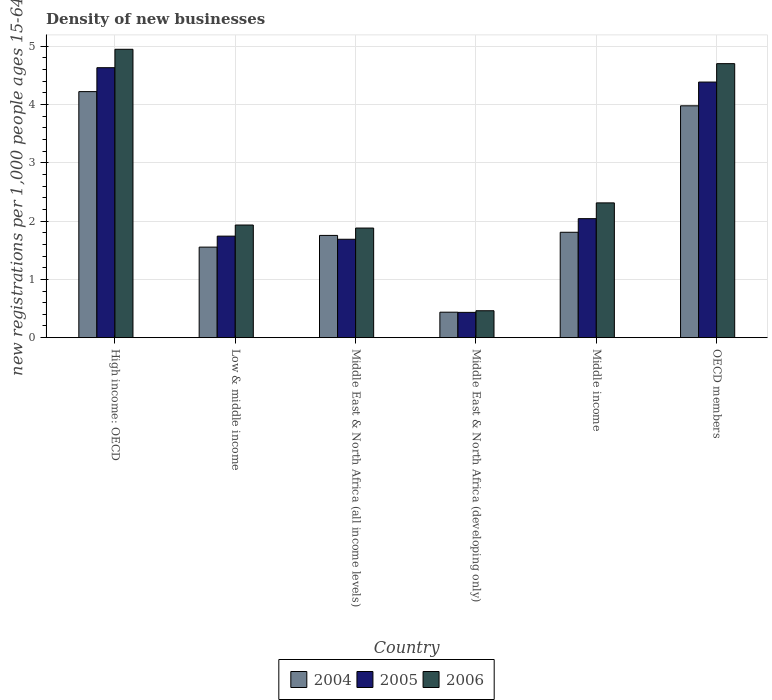How many different coloured bars are there?
Give a very brief answer. 3. Are the number of bars per tick equal to the number of legend labels?
Your answer should be very brief. Yes. Are the number of bars on each tick of the X-axis equal?
Keep it short and to the point. Yes. How many bars are there on the 3rd tick from the right?
Make the answer very short. 3. What is the label of the 5th group of bars from the left?
Make the answer very short. Middle income. In how many cases, is the number of bars for a given country not equal to the number of legend labels?
Your answer should be compact. 0. What is the number of new registrations in 2004 in OECD members?
Ensure brevity in your answer.  3.98. Across all countries, what is the maximum number of new registrations in 2004?
Your answer should be very brief. 4.22. Across all countries, what is the minimum number of new registrations in 2004?
Your answer should be compact. 0.44. In which country was the number of new registrations in 2006 maximum?
Your response must be concise. High income: OECD. In which country was the number of new registrations in 2005 minimum?
Provide a succinct answer. Middle East & North Africa (developing only). What is the total number of new registrations in 2006 in the graph?
Provide a short and direct response. 16.23. What is the difference between the number of new registrations in 2006 in Middle income and that in OECD members?
Provide a succinct answer. -2.39. What is the difference between the number of new registrations in 2004 in Low & middle income and the number of new registrations in 2005 in Middle income?
Your response must be concise. -0.49. What is the average number of new registrations in 2004 per country?
Give a very brief answer. 2.29. What is the difference between the number of new registrations of/in 2005 and number of new registrations of/in 2006 in Middle East & North Africa (all income levels)?
Give a very brief answer. -0.19. In how many countries, is the number of new registrations in 2004 greater than 0.4?
Ensure brevity in your answer.  6. What is the ratio of the number of new registrations in 2005 in Middle East & North Africa (developing only) to that in Middle income?
Make the answer very short. 0.21. Is the number of new registrations in 2004 in High income: OECD less than that in Middle East & North Africa (developing only)?
Offer a terse response. No. Is the difference between the number of new registrations in 2005 in Middle income and OECD members greater than the difference between the number of new registrations in 2006 in Middle income and OECD members?
Your response must be concise. Yes. What is the difference between the highest and the second highest number of new registrations in 2005?
Ensure brevity in your answer.  -2.59. What is the difference between the highest and the lowest number of new registrations in 2005?
Provide a succinct answer. 4.2. What does the 1st bar from the left in Middle East & North Africa (all income levels) represents?
Ensure brevity in your answer.  2004. Is it the case that in every country, the sum of the number of new registrations in 2005 and number of new registrations in 2006 is greater than the number of new registrations in 2004?
Your response must be concise. Yes. How many bars are there?
Provide a short and direct response. 18. How many countries are there in the graph?
Offer a very short reply. 6. Does the graph contain any zero values?
Your answer should be compact. No. Does the graph contain grids?
Provide a short and direct response. Yes. How are the legend labels stacked?
Your answer should be compact. Horizontal. What is the title of the graph?
Your answer should be compact. Density of new businesses. What is the label or title of the Y-axis?
Give a very brief answer. New registrations per 1,0 people ages 15-64. What is the new registrations per 1,000 people ages 15-64 of 2004 in High income: OECD?
Your answer should be very brief. 4.22. What is the new registrations per 1,000 people ages 15-64 in 2005 in High income: OECD?
Provide a short and direct response. 4.63. What is the new registrations per 1,000 people ages 15-64 of 2006 in High income: OECD?
Provide a short and direct response. 4.94. What is the new registrations per 1,000 people ages 15-64 of 2004 in Low & middle income?
Your response must be concise. 1.55. What is the new registrations per 1,000 people ages 15-64 in 2005 in Low & middle income?
Make the answer very short. 1.74. What is the new registrations per 1,000 people ages 15-64 in 2006 in Low & middle income?
Offer a terse response. 1.93. What is the new registrations per 1,000 people ages 15-64 in 2004 in Middle East & North Africa (all income levels)?
Provide a succinct answer. 1.75. What is the new registrations per 1,000 people ages 15-64 in 2005 in Middle East & North Africa (all income levels)?
Keep it short and to the point. 1.69. What is the new registrations per 1,000 people ages 15-64 in 2006 in Middle East & North Africa (all income levels)?
Provide a succinct answer. 1.88. What is the new registrations per 1,000 people ages 15-64 of 2004 in Middle East & North Africa (developing only)?
Keep it short and to the point. 0.44. What is the new registrations per 1,000 people ages 15-64 of 2005 in Middle East & North Africa (developing only)?
Give a very brief answer. 0.43. What is the new registrations per 1,000 people ages 15-64 of 2006 in Middle East & North Africa (developing only)?
Give a very brief answer. 0.46. What is the new registrations per 1,000 people ages 15-64 of 2004 in Middle income?
Make the answer very short. 1.81. What is the new registrations per 1,000 people ages 15-64 of 2005 in Middle income?
Provide a short and direct response. 2.04. What is the new registrations per 1,000 people ages 15-64 in 2006 in Middle income?
Your answer should be very brief. 2.31. What is the new registrations per 1,000 people ages 15-64 in 2004 in OECD members?
Keep it short and to the point. 3.98. What is the new registrations per 1,000 people ages 15-64 of 2005 in OECD members?
Your response must be concise. 4.38. What is the new registrations per 1,000 people ages 15-64 in 2006 in OECD members?
Offer a terse response. 4.7. Across all countries, what is the maximum new registrations per 1,000 people ages 15-64 in 2004?
Your response must be concise. 4.22. Across all countries, what is the maximum new registrations per 1,000 people ages 15-64 in 2005?
Your answer should be compact. 4.63. Across all countries, what is the maximum new registrations per 1,000 people ages 15-64 of 2006?
Provide a short and direct response. 4.94. Across all countries, what is the minimum new registrations per 1,000 people ages 15-64 in 2004?
Your answer should be very brief. 0.44. Across all countries, what is the minimum new registrations per 1,000 people ages 15-64 of 2005?
Provide a succinct answer. 0.43. Across all countries, what is the minimum new registrations per 1,000 people ages 15-64 in 2006?
Offer a terse response. 0.46. What is the total new registrations per 1,000 people ages 15-64 in 2004 in the graph?
Offer a terse response. 13.74. What is the total new registrations per 1,000 people ages 15-64 of 2005 in the graph?
Offer a very short reply. 14.92. What is the total new registrations per 1,000 people ages 15-64 of 2006 in the graph?
Offer a terse response. 16.23. What is the difference between the new registrations per 1,000 people ages 15-64 in 2004 in High income: OECD and that in Low & middle income?
Your answer should be very brief. 2.67. What is the difference between the new registrations per 1,000 people ages 15-64 in 2005 in High income: OECD and that in Low & middle income?
Your answer should be compact. 2.89. What is the difference between the new registrations per 1,000 people ages 15-64 of 2006 in High income: OECD and that in Low & middle income?
Make the answer very short. 3.01. What is the difference between the new registrations per 1,000 people ages 15-64 of 2004 in High income: OECD and that in Middle East & North Africa (all income levels)?
Offer a very short reply. 2.47. What is the difference between the new registrations per 1,000 people ages 15-64 of 2005 in High income: OECD and that in Middle East & North Africa (all income levels)?
Offer a very short reply. 2.94. What is the difference between the new registrations per 1,000 people ages 15-64 of 2006 in High income: OECD and that in Middle East & North Africa (all income levels)?
Provide a succinct answer. 3.07. What is the difference between the new registrations per 1,000 people ages 15-64 of 2004 in High income: OECD and that in Middle East & North Africa (developing only)?
Your answer should be very brief. 3.78. What is the difference between the new registrations per 1,000 people ages 15-64 in 2005 in High income: OECD and that in Middle East & North Africa (developing only)?
Offer a very short reply. 4.2. What is the difference between the new registrations per 1,000 people ages 15-64 of 2006 in High income: OECD and that in Middle East & North Africa (developing only)?
Ensure brevity in your answer.  4.48. What is the difference between the new registrations per 1,000 people ages 15-64 in 2004 in High income: OECD and that in Middle income?
Your answer should be compact. 2.41. What is the difference between the new registrations per 1,000 people ages 15-64 of 2005 in High income: OECD and that in Middle income?
Keep it short and to the point. 2.59. What is the difference between the new registrations per 1,000 people ages 15-64 of 2006 in High income: OECD and that in Middle income?
Provide a succinct answer. 2.63. What is the difference between the new registrations per 1,000 people ages 15-64 in 2004 in High income: OECD and that in OECD members?
Offer a terse response. 0.24. What is the difference between the new registrations per 1,000 people ages 15-64 in 2005 in High income: OECD and that in OECD members?
Offer a very short reply. 0.25. What is the difference between the new registrations per 1,000 people ages 15-64 of 2006 in High income: OECD and that in OECD members?
Offer a terse response. 0.25. What is the difference between the new registrations per 1,000 people ages 15-64 of 2004 in Low & middle income and that in Middle East & North Africa (all income levels)?
Provide a succinct answer. -0.2. What is the difference between the new registrations per 1,000 people ages 15-64 of 2005 in Low & middle income and that in Middle East & North Africa (all income levels)?
Your answer should be very brief. 0.05. What is the difference between the new registrations per 1,000 people ages 15-64 of 2006 in Low & middle income and that in Middle East & North Africa (all income levels)?
Your answer should be very brief. 0.05. What is the difference between the new registrations per 1,000 people ages 15-64 of 2004 in Low & middle income and that in Middle East & North Africa (developing only)?
Offer a very short reply. 1.12. What is the difference between the new registrations per 1,000 people ages 15-64 of 2005 in Low & middle income and that in Middle East & North Africa (developing only)?
Ensure brevity in your answer.  1.31. What is the difference between the new registrations per 1,000 people ages 15-64 of 2006 in Low & middle income and that in Middle East & North Africa (developing only)?
Give a very brief answer. 1.47. What is the difference between the new registrations per 1,000 people ages 15-64 of 2004 in Low & middle income and that in Middle income?
Give a very brief answer. -0.25. What is the difference between the new registrations per 1,000 people ages 15-64 in 2005 in Low & middle income and that in Middle income?
Make the answer very short. -0.3. What is the difference between the new registrations per 1,000 people ages 15-64 of 2006 in Low & middle income and that in Middle income?
Your response must be concise. -0.38. What is the difference between the new registrations per 1,000 people ages 15-64 in 2004 in Low & middle income and that in OECD members?
Your answer should be compact. -2.42. What is the difference between the new registrations per 1,000 people ages 15-64 of 2005 in Low & middle income and that in OECD members?
Provide a succinct answer. -2.64. What is the difference between the new registrations per 1,000 people ages 15-64 of 2006 in Low & middle income and that in OECD members?
Keep it short and to the point. -2.77. What is the difference between the new registrations per 1,000 people ages 15-64 of 2004 in Middle East & North Africa (all income levels) and that in Middle East & North Africa (developing only)?
Provide a short and direct response. 1.32. What is the difference between the new registrations per 1,000 people ages 15-64 in 2005 in Middle East & North Africa (all income levels) and that in Middle East & North Africa (developing only)?
Provide a short and direct response. 1.25. What is the difference between the new registrations per 1,000 people ages 15-64 of 2006 in Middle East & North Africa (all income levels) and that in Middle East & North Africa (developing only)?
Offer a very short reply. 1.42. What is the difference between the new registrations per 1,000 people ages 15-64 of 2004 in Middle East & North Africa (all income levels) and that in Middle income?
Offer a terse response. -0.05. What is the difference between the new registrations per 1,000 people ages 15-64 in 2005 in Middle East & North Africa (all income levels) and that in Middle income?
Your answer should be compact. -0.35. What is the difference between the new registrations per 1,000 people ages 15-64 in 2006 in Middle East & North Africa (all income levels) and that in Middle income?
Provide a short and direct response. -0.43. What is the difference between the new registrations per 1,000 people ages 15-64 of 2004 in Middle East & North Africa (all income levels) and that in OECD members?
Your answer should be very brief. -2.22. What is the difference between the new registrations per 1,000 people ages 15-64 of 2005 in Middle East & North Africa (all income levels) and that in OECD members?
Provide a short and direct response. -2.7. What is the difference between the new registrations per 1,000 people ages 15-64 of 2006 in Middle East & North Africa (all income levels) and that in OECD members?
Keep it short and to the point. -2.82. What is the difference between the new registrations per 1,000 people ages 15-64 of 2004 in Middle East & North Africa (developing only) and that in Middle income?
Keep it short and to the point. -1.37. What is the difference between the new registrations per 1,000 people ages 15-64 of 2005 in Middle East & North Africa (developing only) and that in Middle income?
Give a very brief answer. -1.61. What is the difference between the new registrations per 1,000 people ages 15-64 in 2006 in Middle East & North Africa (developing only) and that in Middle income?
Offer a very short reply. -1.85. What is the difference between the new registrations per 1,000 people ages 15-64 in 2004 in Middle East & North Africa (developing only) and that in OECD members?
Keep it short and to the point. -3.54. What is the difference between the new registrations per 1,000 people ages 15-64 in 2005 in Middle East & North Africa (developing only) and that in OECD members?
Your response must be concise. -3.95. What is the difference between the new registrations per 1,000 people ages 15-64 in 2006 in Middle East & North Africa (developing only) and that in OECD members?
Ensure brevity in your answer.  -4.24. What is the difference between the new registrations per 1,000 people ages 15-64 of 2004 in Middle income and that in OECD members?
Your response must be concise. -2.17. What is the difference between the new registrations per 1,000 people ages 15-64 in 2005 in Middle income and that in OECD members?
Your answer should be compact. -2.34. What is the difference between the new registrations per 1,000 people ages 15-64 of 2006 in Middle income and that in OECD members?
Your response must be concise. -2.39. What is the difference between the new registrations per 1,000 people ages 15-64 in 2004 in High income: OECD and the new registrations per 1,000 people ages 15-64 in 2005 in Low & middle income?
Your answer should be compact. 2.48. What is the difference between the new registrations per 1,000 people ages 15-64 of 2004 in High income: OECD and the new registrations per 1,000 people ages 15-64 of 2006 in Low & middle income?
Offer a very short reply. 2.29. What is the difference between the new registrations per 1,000 people ages 15-64 in 2005 in High income: OECD and the new registrations per 1,000 people ages 15-64 in 2006 in Low & middle income?
Ensure brevity in your answer.  2.7. What is the difference between the new registrations per 1,000 people ages 15-64 in 2004 in High income: OECD and the new registrations per 1,000 people ages 15-64 in 2005 in Middle East & North Africa (all income levels)?
Ensure brevity in your answer.  2.53. What is the difference between the new registrations per 1,000 people ages 15-64 in 2004 in High income: OECD and the new registrations per 1,000 people ages 15-64 in 2006 in Middle East & North Africa (all income levels)?
Make the answer very short. 2.34. What is the difference between the new registrations per 1,000 people ages 15-64 of 2005 in High income: OECD and the new registrations per 1,000 people ages 15-64 of 2006 in Middle East & North Africa (all income levels)?
Keep it short and to the point. 2.75. What is the difference between the new registrations per 1,000 people ages 15-64 of 2004 in High income: OECD and the new registrations per 1,000 people ages 15-64 of 2005 in Middle East & North Africa (developing only)?
Make the answer very short. 3.79. What is the difference between the new registrations per 1,000 people ages 15-64 of 2004 in High income: OECD and the new registrations per 1,000 people ages 15-64 of 2006 in Middle East & North Africa (developing only)?
Give a very brief answer. 3.76. What is the difference between the new registrations per 1,000 people ages 15-64 of 2005 in High income: OECD and the new registrations per 1,000 people ages 15-64 of 2006 in Middle East & North Africa (developing only)?
Your answer should be very brief. 4.17. What is the difference between the new registrations per 1,000 people ages 15-64 of 2004 in High income: OECD and the new registrations per 1,000 people ages 15-64 of 2005 in Middle income?
Ensure brevity in your answer.  2.18. What is the difference between the new registrations per 1,000 people ages 15-64 in 2004 in High income: OECD and the new registrations per 1,000 people ages 15-64 in 2006 in Middle income?
Your answer should be very brief. 1.91. What is the difference between the new registrations per 1,000 people ages 15-64 in 2005 in High income: OECD and the new registrations per 1,000 people ages 15-64 in 2006 in Middle income?
Offer a terse response. 2.32. What is the difference between the new registrations per 1,000 people ages 15-64 of 2004 in High income: OECD and the new registrations per 1,000 people ages 15-64 of 2005 in OECD members?
Provide a short and direct response. -0.16. What is the difference between the new registrations per 1,000 people ages 15-64 in 2004 in High income: OECD and the new registrations per 1,000 people ages 15-64 in 2006 in OECD members?
Your answer should be compact. -0.48. What is the difference between the new registrations per 1,000 people ages 15-64 of 2005 in High income: OECD and the new registrations per 1,000 people ages 15-64 of 2006 in OECD members?
Your answer should be very brief. -0.07. What is the difference between the new registrations per 1,000 people ages 15-64 of 2004 in Low & middle income and the new registrations per 1,000 people ages 15-64 of 2005 in Middle East & North Africa (all income levels)?
Your answer should be very brief. -0.13. What is the difference between the new registrations per 1,000 people ages 15-64 in 2004 in Low & middle income and the new registrations per 1,000 people ages 15-64 in 2006 in Middle East & North Africa (all income levels)?
Your answer should be very brief. -0.33. What is the difference between the new registrations per 1,000 people ages 15-64 in 2005 in Low & middle income and the new registrations per 1,000 people ages 15-64 in 2006 in Middle East & North Africa (all income levels)?
Your answer should be very brief. -0.14. What is the difference between the new registrations per 1,000 people ages 15-64 of 2004 in Low & middle income and the new registrations per 1,000 people ages 15-64 of 2005 in Middle East & North Africa (developing only)?
Offer a very short reply. 1.12. What is the difference between the new registrations per 1,000 people ages 15-64 of 2005 in Low & middle income and the new registrations per 1,000 people ages 15-64 of 2006 in Middle East & North Africa (developing only)?
Offer a very short reply. 1.28. What is the difference between the new registrations per 1,000 people ages 15-64 in 2004 in Low & middle income and the new registrations per 1,000 people ages 15-64 in 2005 in Middle income?
Offer a terse response. -0.49. What is the difference between the new registrations per 1,000 people ages 15-64 of 2004 in Low & middle income and the new registrations per 1,000 people ages 15-64 of 2006 in Middle income?
Your response must be concise. -0.76. What is the difference between the new registrations per 1,000 people ages 15-64 in 2005 in Low & middle income and the new registrations per 1,000 people ages 15-64 in 2006 in Middle income?
Your answer should be compact. -0.57. What is the difference between the new registrations per 1,000 people ages 15-64 in 2004 in Low & middle income and the new registrations per 1,000 people ages 15-64 in 2005 in OECD members?
Your answer should be compact. -2.83. What is the difference between the new registrations per 1,000 people ages 15-64 in 2004 in Low & middle income and the new registrations per 1,000 people ages 15-64 in 2006 in OECD members?
Provide a short and direct response. -3.15. What is the difference between the new registrations per 1,000 people ages 15-64 in 2005 in Low & middle income and the new registrations per 1,000 people ages 15-64 in 2006 in OECD members?
Your answer should be compact. -2.96. What is the difference between the new registrations per 1,000 people ages 15-64 of 2004 in Middle East & North Africa (all income levels) and the new registrations per 1,000 people ages 15-64 of 2005 in Middle East & North Africa (developing only)?
Ensure brevity in your answer.  1.32. What is the difference between the new registrations per 1,000 people ages 15-64 in 2004 in Middle East & North Africa (all income levels) and the new registrations per 1,000 people ages 15-64 in 2006 in Middle East & North Africa (developing only)?
Make the answer very short. 1.29. What is the difference between the new registrations per 1,000 people ages 15-64 in 2005 in Middle East & North Africa (all income levels) and the new registrations per 1,000 people ages 15-64 in 2006 in Middle East & North Africa (developing only)?
Your answer should be compact. 1.23. What is the difference between the new registrations per 1,000 people ages 15-64 of 2004 in Middle East & North Africa (all income levels) and the new registrations per 1,000 people ages 15-64 of 2005 in Middle income?
Offer a terse response. -0.29. What is the difference between the new registrations per 1,000 people ages 15-64 in 2004 in Middle East & North Africa (all income levels) and the new registrations per 1,000 people ages 15-64 in 2006 in Middle income?
Give a very brief answer. -0.56. What is the difference between the new registrations per 1,000 people ages 15-64 in 2005 in Middle East & North Africa (all income levels) and the new registrations per 1,000 people ages 15-64 in 2006 in Middle income?
Offer a terse response. -0.62. What is the difference between the new registrations per 1,000 people ages 15-64 in 2004 in Middle East & North Africa (all income levels) and the new registrations per 1,000 people ages 15-64 in 2005 in OECD members?
Offer a terse response. -2.63. What is the difference between the new registrations per 1,000 people ages 15-64 in 2004 in Middle East & North Africa (all income levels) and the new registrations per 1,000 people ages 15-64 in 2006 in OECD members?
Ensure brevity in your answer.  -2.95. What is the difference between the new registrations per 1,000 people ages 15-64 of 2005 in Middle East & North Africa (all income levels) and the new registrations per 1,000 people ages 15-64 of 2006 in OECD members?
Ensure brevity in your answer.  -3.01. What is the difference between the new registrations per 1,000 people ages 15-64 of 2004 in Middle East & North Africa (developing only) and the new registrations per 1,000 people ages 15-64 of 2005 in Middle income?
Give a very brief answer. -1.6. What is the difference between the new registrations per 1,000 people ages 15-64 in 2004 in Middle East & North Africa (developing only) and the new registrations per 1,000 people ages 15-64 in 2006 in Middle income?
Offer a terse response. -1.87. What is the difference between the new registrations per 1,000 people ages 15-64 in 2005 in Middle East & North Africa (developing only) and the new registrations per 1,000 people ages 15-64 in 2006 in Middle income?
Offer a terse response. -1.88. What is the difference between the new registrations per 1,000 people ages 15-64 in 2004 in Middle East & North Africa (developing only) and the new registrations per 1,000 people ages 15-64 in 2005 in OECD members?
Make the answer very short. -3.95. What is the difference between the new registrations per 1,000 people ages 15-64 in 2004 in Middle East & North Africa (developing only) and the new registrations per 1,000 people ages 15-64 in 2006 in OECD members?
Offer a terse response. -4.26. What is the difference between the new registrations per 1,000 people ages 15-64 in 2005 in Middle East & North Africa (developing only) and the new registrations per 1,000 people ages 15-64 in 2006 in OECD members?
Provide a short and direct response. -4.26. What is the difference between the new registrations per 1,000 people ages 15-64 in 2004 in Middle income and the new registrations per 1,000 people ages 15-64 in 2005 in OECD members?
Ensure brevity in your answer.  -2.58. What is the difference between the new registrations per 1,000 people ages 15-64 in 2004 in Middle income and the new registrations per 1,000 people ages 15-64 in 2006 in OECD members?
Give a very brief answer. -2.89. What is the difference between the new registrations per 1,000 people ages 15-64 in 2005 in Middle income and the new registrations per 1,000 people ages 15-64 in 2006 in OECD members?
Offer a very short reply. -2.66. What is the average new registrations per 1,000 people ages 15-64 in 2004 per country?
Your answer should be compact. 2.29. What is the average new registrations per 1,000 people ages 15-64 in 2005 per country?
Provide a short and direct response. 2.49. What is the average new registrations per 1,000 people ages 15-64 of 2006 per country?
Your response must be concise. 2.7. What is the difference between the new registrations per 1,000 people ages 15-64 of 2004 and new registrations per 1,000 people ages 15-64 of 2005 in High income: OECD?
Give a very brief answer. -0.41. What is the difference between the new registrations per 1,000 people ages 15-64 of 2004 and new registrations per 1,000 people ages 15-64 of 2006 in High income: OECD?
Your answer should be very brief. -0.73. What is the difference between the new registrations per 1,000 people ages 15-64 of 2005 and new registrations per 1,000 people ages 15-64 of 2006 in High income: OECD?
Offer a very short reply. -0.32. What is the difference between the new registrations per 1,000 people ages 15-64 of 2004 and new registrations per 1,000 people ages 15-64 of 2005 in Low & middle income?
Your answer should be compact. -0.19. What is the difference between the new registrations per 1,000 people ages 15-64 of 2004 and new registrations per 1,000 people ages 15-64 of 2006 in Low & middle income?
Provide a succinct answer. -0.38. What is the difference between the new registrations per 1,000 people ages 15-64 of 2005 and new registrations per 1,000 people ages 15-64 of 2006 in Low & middle income?
Your response must be concise. -0.19. What is the difference between the new registrations per 1,000 people ages 15-64 in 2004 and new registrations per 1,000 people ages 15-64 in 2005 in Middle East & North Africa (all income levels)?
Ensure brevity in your answer.  0.07. What is the difference between the new registrations per 1,000 people ages 15-64 of 2004 and new registrations per 1,000 people ages 15-64 of 2006 in Middle East & North Africa (all income levels)?
Offer a terse response. -0.13. What is the difference between the new registrations per 1,000 people ages 15-64 of 2005 and new registrations per 1,000 people ages 15-64 of 2006 in Middle East & North Africa (all income levels)?
Provide a succinct answer. -0.19. What is the difference between the new registrations per 1,000 people ages 15-64 of 2004 and new registrations per 1,000 people ages 15-64 of 2005 in Middle East & North Africa (developing only)?
Make the answer very short. 0. What is the difference between the new registrations per 1,000 people ages 15-64 of 2004 and new registrations per 1,000 people ages 15-64 of 2006 in Middle East & North Africa (developing only)?
Give a very brief answer. -0.02. What is the difference between the new registrations per 1,000 people ages 15-64 in 2005 and new registrations per 1,000 people ages 15-64 in 2006 in Middle East & North Africa (developing only)?
Make the answer very short. -0.03. What is the difference between the new registrations per 1,000 people ages 15-64 in 2004 and new registrations per 1,000 people ages 15-64 in 2005 in Middle income?
Give a very brief answer. -0.23. What is the difference between the new registrations per 1,000 people ages 15-64 in 2004 and new registrations per 1,000 people ages 15-64 in 2006 in Middle income?
Offer a very short reply. -0.5. What is the difference between the new registrations per 1,000 people ages 15-64 in 2005 and new registrations per 1,000 people ages 15-64 in 2006 in Middle income?
Ensure brevity in your answer.  -0.27. What is the difference between the new registrations per 1,000 people ages 15-64 in 2004 and new registrations per 1,000 people ages 15-64 in 2005 in OECD members?
Offer a very short reply. -0.41. What is the difference between the new registrations per 1,000 people ages 15-64 of 2004 and new registrations per 1,000 people ages 15-64 of 2006 in OECD members?
Make the answer very short. -0.72. What is the difference between the new registrations per 1,000 people ages 15-64 in 2005 and new registrations per 1,000 people ages 15-64 in 2006 in OECD members?
Offer a very short reply. -0.32. What is the ratio of the new registrations per 1,000 people ages 15-64 in 2004 in High income: OECD to that in Low & middle income?
Your answer should be compact. 2.72. What is the ratio of the new registrations per 1,000 people ages 15-64 of 2005 in High income: OECD to that in Low & middle income?
Make the answer very short. 2.66. What is the ratio of the new registrations per 1,000 people ages 15-64 in 2006 in High income: OECD to that in Low & middle income?
Ensure brevity in your answer.  2.56. What is the ratio of the new registrations per 1,000 people ages 15-64 of 2004 in High income: OECD to that in Middle East & North Africa (all income levels)?
Your response must be concise. 2.41. What is the ratio of the new registrations per 1,000 people ages 15-64 in 2005 in High income: OECD to that in Middle East & North Africa (all income levels)?
Provide a succinct answer. 2.74. What is the ratio of the new registrations per 1,000 people ages 15-64 of 2006 in High income: OECD to that in Middle East & North Africa (all income levels)?
Your answer should be compact. 2.63. What is the ratio of the new registrations per 1,000 people ages 15-64 in 2004 in High income: OECD to that in Middle East & North Africa (developing only)?
Your answer should be compact. 9.66. What is the ratio of the new registrations per 1,000 people ages 15-64 in 2005 in High income: OECD to that in Middle East & North Africa (developing only)?
Ensure brevity in your answer.  10.67. What is the ratio of the new registrations per 1,000 people ages 15-64 in 2006 in High income: OECD to that in Middle East & North Africa (developing only)?
Provide a succinct answer. 10.71. What is the ratio of the new registrations per 1,000 people ages 15-64 in 2004 in High income: OECD to that in Middle income?
Give a very brief answer. 2.33. What is the ratio of the new registrations per 1,000 people ages 15-64 in 2005 in High income: OECD to that in Middle income?
Give a very brief answer. 2.27. What is the ratio of the new registrations per 1,000 people ages 15-64 of 2006 in High income: OECD to that in Middle income?
Your response must be concise. 2.14. What is the ratio of the new registrations per 1,000 people ages 15-64 of 2004 in High income: OECD to that in OECD members?
Keep it short and to the point. 1.06. What is the ratio of the new registrations per 1,000 people ages 15-64 of 2005 in High income: OECD to that in OECD members?
Your response must be concise. 1.06. What is the ratio of the new registrations per 1,000 people ages 15-64 in 2006 in High income: OECD to that in OECD members?
Ensure brevity in your answer.  1.05. What is the ratio of the new registrations per 1,000 people ages 15-64 in 2004 in Low & middle income to that in Middle East & North Africa (all income levels)?
Provide a succinct answer. 0.89. What is the ratio of the new registrations per 1,000 people ages 15-64 in 2005 in Low & middle income to that in Middle East & North Africa (all income levels)?
Make the answer very short. 1.03. What is the ratio of the new registrations per 1,000 people ages 15-64 of 2006 in Low & middle income to that in Middle East & North Africa (all income levels)?
Provide a succinct answer. 1.03. What is the ratio of the new registrations per 1,000 people ages 15-64 in 2004 in Low & middle income to that in Middle East & North Africa (developing only)?
Keep it short and to the point. 3.55. What is the ratio of the new registrations per 1,000 people ages 15-64 in 2005 in Low & middle income to that in Middle East & North Africa (developing only)?
Your response must be concise. 4.01. What is the ratio of the new registrations per 1,000 people ages 15-64 of 2006 in Low & middle income to that in Middle East & North Africa (developing only)?
Your answer should be compact. 4.18. What is the ratio of the new registrations per 1,000 people ages 15-64 of 2004 in Low & middle income to that in Middle income?
Provide a short and direct response. 0.86. What is the ratio of the new registrations per 1,000 people ages 15-64 of 2005 in Low & middle income to that in Middle income?
Provide a succinct answer. 0.85. What is the ratio of the new registrations per 1,000 people ages 15-64 in 2006 in Low & middle income to that in Middle income?
Provide a succinct answer. 0.84. What is the ratio of the new registrations per 1,000 people ages 15-64 in 2004 in Low & middle income to that in OECD members?
Provide a succinct answer. 0.39. What is the ratio of the new registrations per 1,000 people ages 15-64 of 2005 in Low & middle income to that in OECD members?
Offer a terse response. 0.4. What is the ratio of the new registrations per 1,000 people ages 15-64 of 2006 in Low & middle income to that in OECD members?
Your answer should be very brief. 0.41. What is the ratio of the new registrations per 1,000 people ages 15-64 of 2004 in Middle East & North Africa (all income levels) to that in Middle East & North Africa (developing only)?
Give a very brief answer. 4.01. What is the ratio of the new registrations per 1,000 people ages 15-64 in 2005 in Middle East & North Africa (all income levels) to that in Middle East & North Africa (developing only)?
Your answer should be compact. 3.89. What is the ratio of the new registrations per 1,000 people ages 15-64 in 2006 in Middle East & North Africa (all income levels) to that in Middle East & North Africa (developing only)?
Provide a succinct answer. 4.07. What is the ratio of the new registrations per 1,000 people ages 15-64 in 2004 in Middle East & North Africa (all income levels) to that in Middle income?
Your answer should be compact. 0.97. What is the ratio of the new registrations per 1,000 people ages 15-64 in 2005 in Middle East & North Africa (all income levels) to that in Middle income?
Provide a succinct answer. 0.83. What is the ratio of the new registrations per 1,000 people ages 15-64 in 2006 in Middle East & North Africa (all income levels) to that in Middle income?
Keep it short and to the point. 0.81. What is the ratio of the new registrations per 1,000 people ages 15-64 of 2004 in Middle East & North Africa (all income levels) to that in OECD members?
Give a very brief answer. 0.44. What is the ratio of the new registrations per 1,000 people ages 15-64 of 2005 in Middle East & North Africa (all income levels) to that in OECD members?
Give a very brief answer. 0.39. What is the ratio of the new registrations per 1,000 people ages 15-64 in 2006 in Middle East & North Africa (all income levels) to that in OECD members?
Your response must be concise. 0.4. What is the ratio of the new registrations per 1,000 people ages 15-64 in 2004 in Middle East & North Africa (developing only) to that in Middle income?
Offer a terse response. 0.24. What is the ratio of the new registrations per 1,000 people ages 15-64 in 2005 in Middle East & North Africa (developing only) to that in Middle income?
Your answer should be compact. 0.21. What is the ratio of the new registrations per 1,000 people ages 15-64 of 2006 in Middle East & North Africa (developing only) to that in Middle income?
Provide a short and direct response. 0.2. What is the ratio of the new registrations per 1,000 people ages 15-64 of 2004 in Middle East & North Africa (developing only) to that in OECD members?
Provide a short and direct response. 0.11. What is the ratio of the new registrations per 1,000 people ages 15-64 in 2005 in Middle East & North Africa (developing only) to that in OECD members?
Give a very brief answer. 0.1. What is the ratio of the new registrations per 1,000 people ages 15-64 in 2006 in Middle East & North Africa (developing only) to that in OECD members?
Make the answer very short. 0.1. What is the ratio of the new registrations per 1,000 people ages 15-64 in 2004 in Middle income to that in OECD members?
Keep it short and to the point. 0.45. What is the ratio of the new registrations per 1,000 people ages 15-64 in 2005 in Middle income to that in OECD members?
Provide a succinct answer. 0.47. What is the ratio of the new registrations per 1,000 people ages 15-64 of 2006 in Middle income to that in OECD members?
Your answer should be very brief. 0.49. What is the difference between the highest and the second highest new registrations per 1,000 people ages 15-64 in 2004?
Make the answer very short. 0.24. What is the difference between the highest and the second highest new registrations per 1,000 people ages 15-64 in 2005?
Make the answer very short. 0.25. What is the difference between the highest and the second highest new registrations per 1,000 people ages 15-64 of 2006?
Make the answer very short. 0.25. What is the difference between the highest and the lowest new registrations per 1,000 people ages 15-64 of 2004?
Your response must be concise. 3.78. What is the difference between the highest and the lowest new registrations per 1,000 people ages 15-64 of 2005?
Provide a succinct answer. 4.2. What is the difference between the highest and the lowest new registrations per 1,000 people ages 15-64 in 2006?
Your answer should be compact. 4.48. 